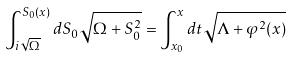Convert formula to latex. <formula><loc_0><loc_0><loc_500><loc_500>\int ^ { S _ { 0 } ( x ) } _ { i \sqrt { \Omega } } { d S _ { 0 } \sqrt { \Omega + S _ { 0 } ^ { 2 } } } = \int ^ { x } _ { x _ { 0 } } { d t \sqrt { \Lambda + \varphi ^ { 2 } ( x ) } }</formula> 